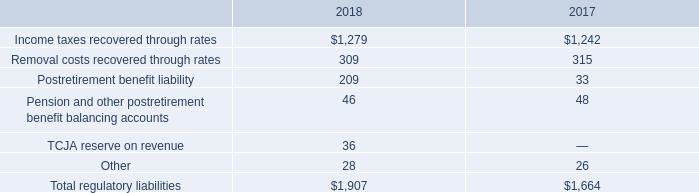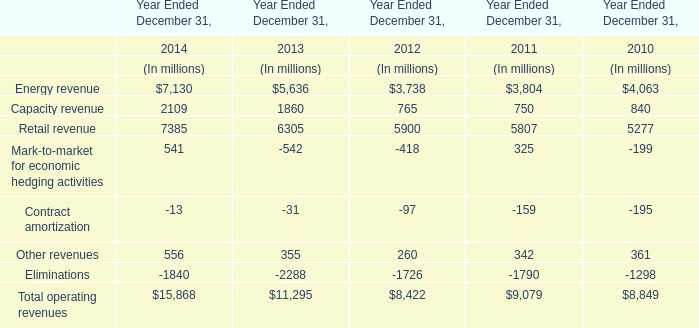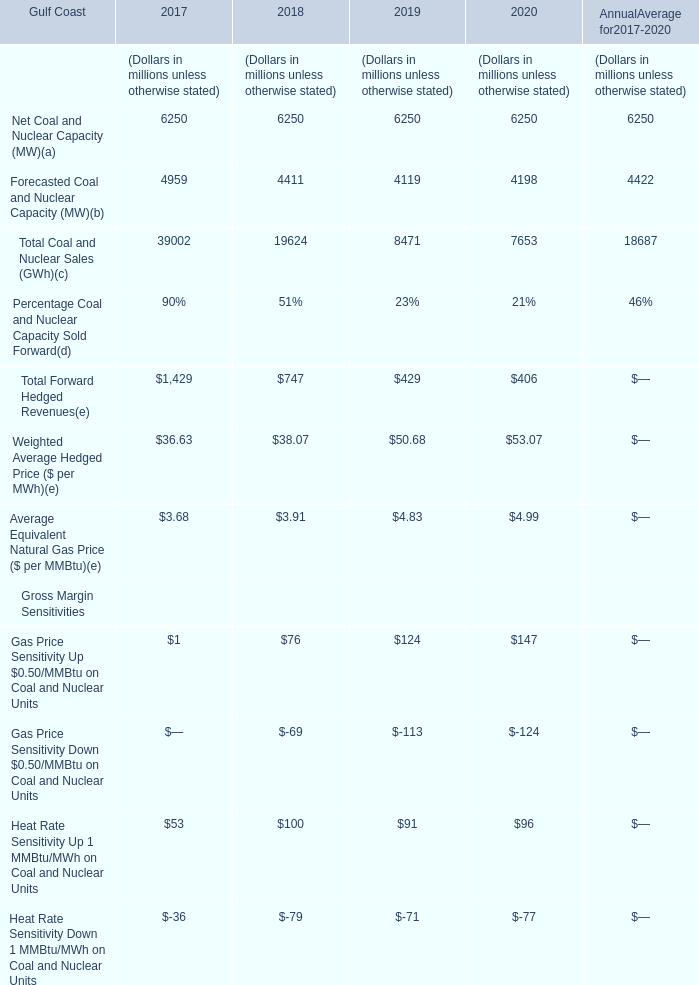Which year is Forecasted Coal and Nuclear Capacity the lowest? 
Answer: 2019. 